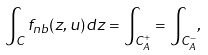Convert formula to latex. <formula><loc_0><loc_0><loc_500><loc_500>\int _ { C } f _ { n b } ( z , u ) d z = \int _ { C _ { A } ^ { + } } = \int _ { C _ { A } ^ { - } } ,</formula> 